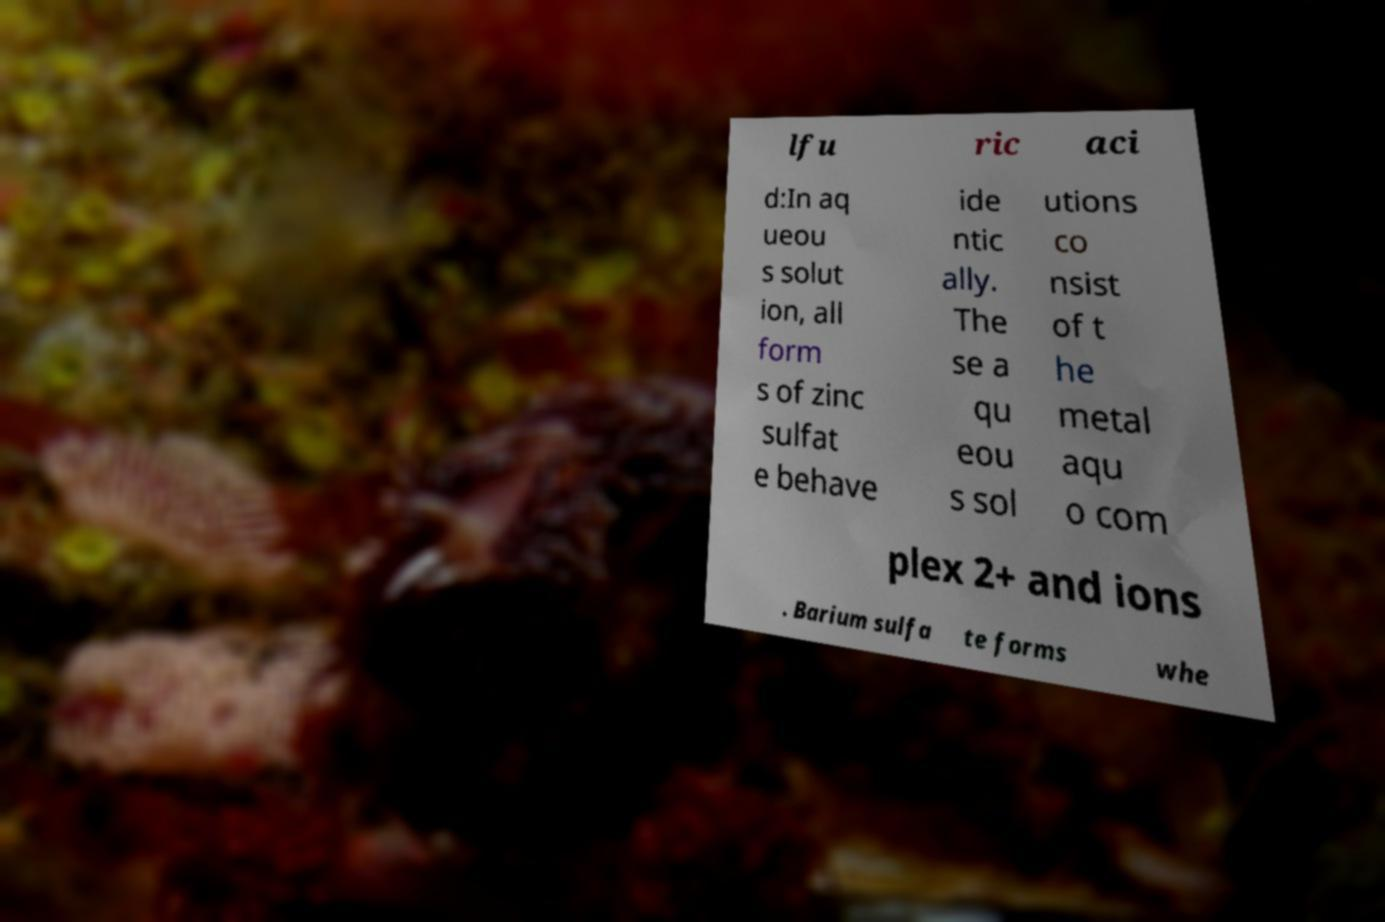For documentation purposes, I need the text within this image transcribed. Could you provide that? lfu ric aci d:In aq ueou s solut ion, all form s of zinc sulfat e behave ide ntic ally. The se a qu eou s sol utions co nsist of t he metal aqu o com plex 2+ and ions . Barium sulfa te forms whe 